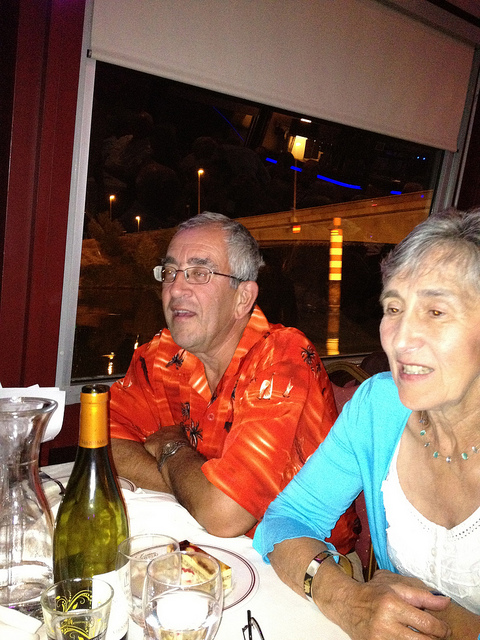Describe a realistic long scenario for this image. John and Mary have been married for over fifty years. Tonight, they're celebrating their anniversary at their favorite waterfront restaurant. The place is quaint with dim lighting and a romantic ambiance. John, wearing his favorite orange Hawaiian shirt, a memento from their trip to Hawaii, passionately recounts the story of their first meeting to a group of diners at the adjacent table, with Mary adding details and laughing at his exaggerated tales. The evening progresses with toasts, laughter, and shared memories, as they cherish each other’s company, surrounded by the love and warmth of a familiar setting. 